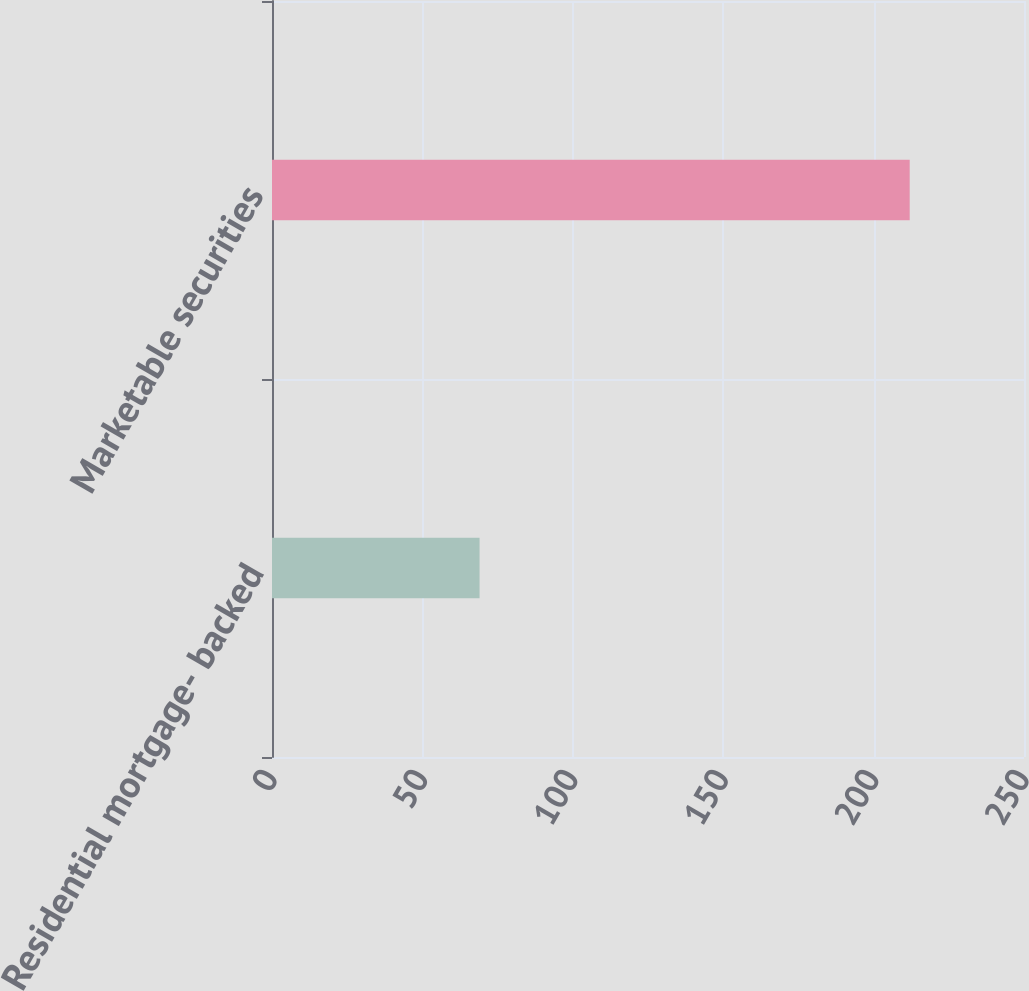Convert chart to OTSL. <chart><loc_0><loc_0><loc_500><loc_500><bar_chart><fcel>Residential mortgage- backed<fcel>Marketable securities<nl><fcel>69<fcel>212<nl></chart> 